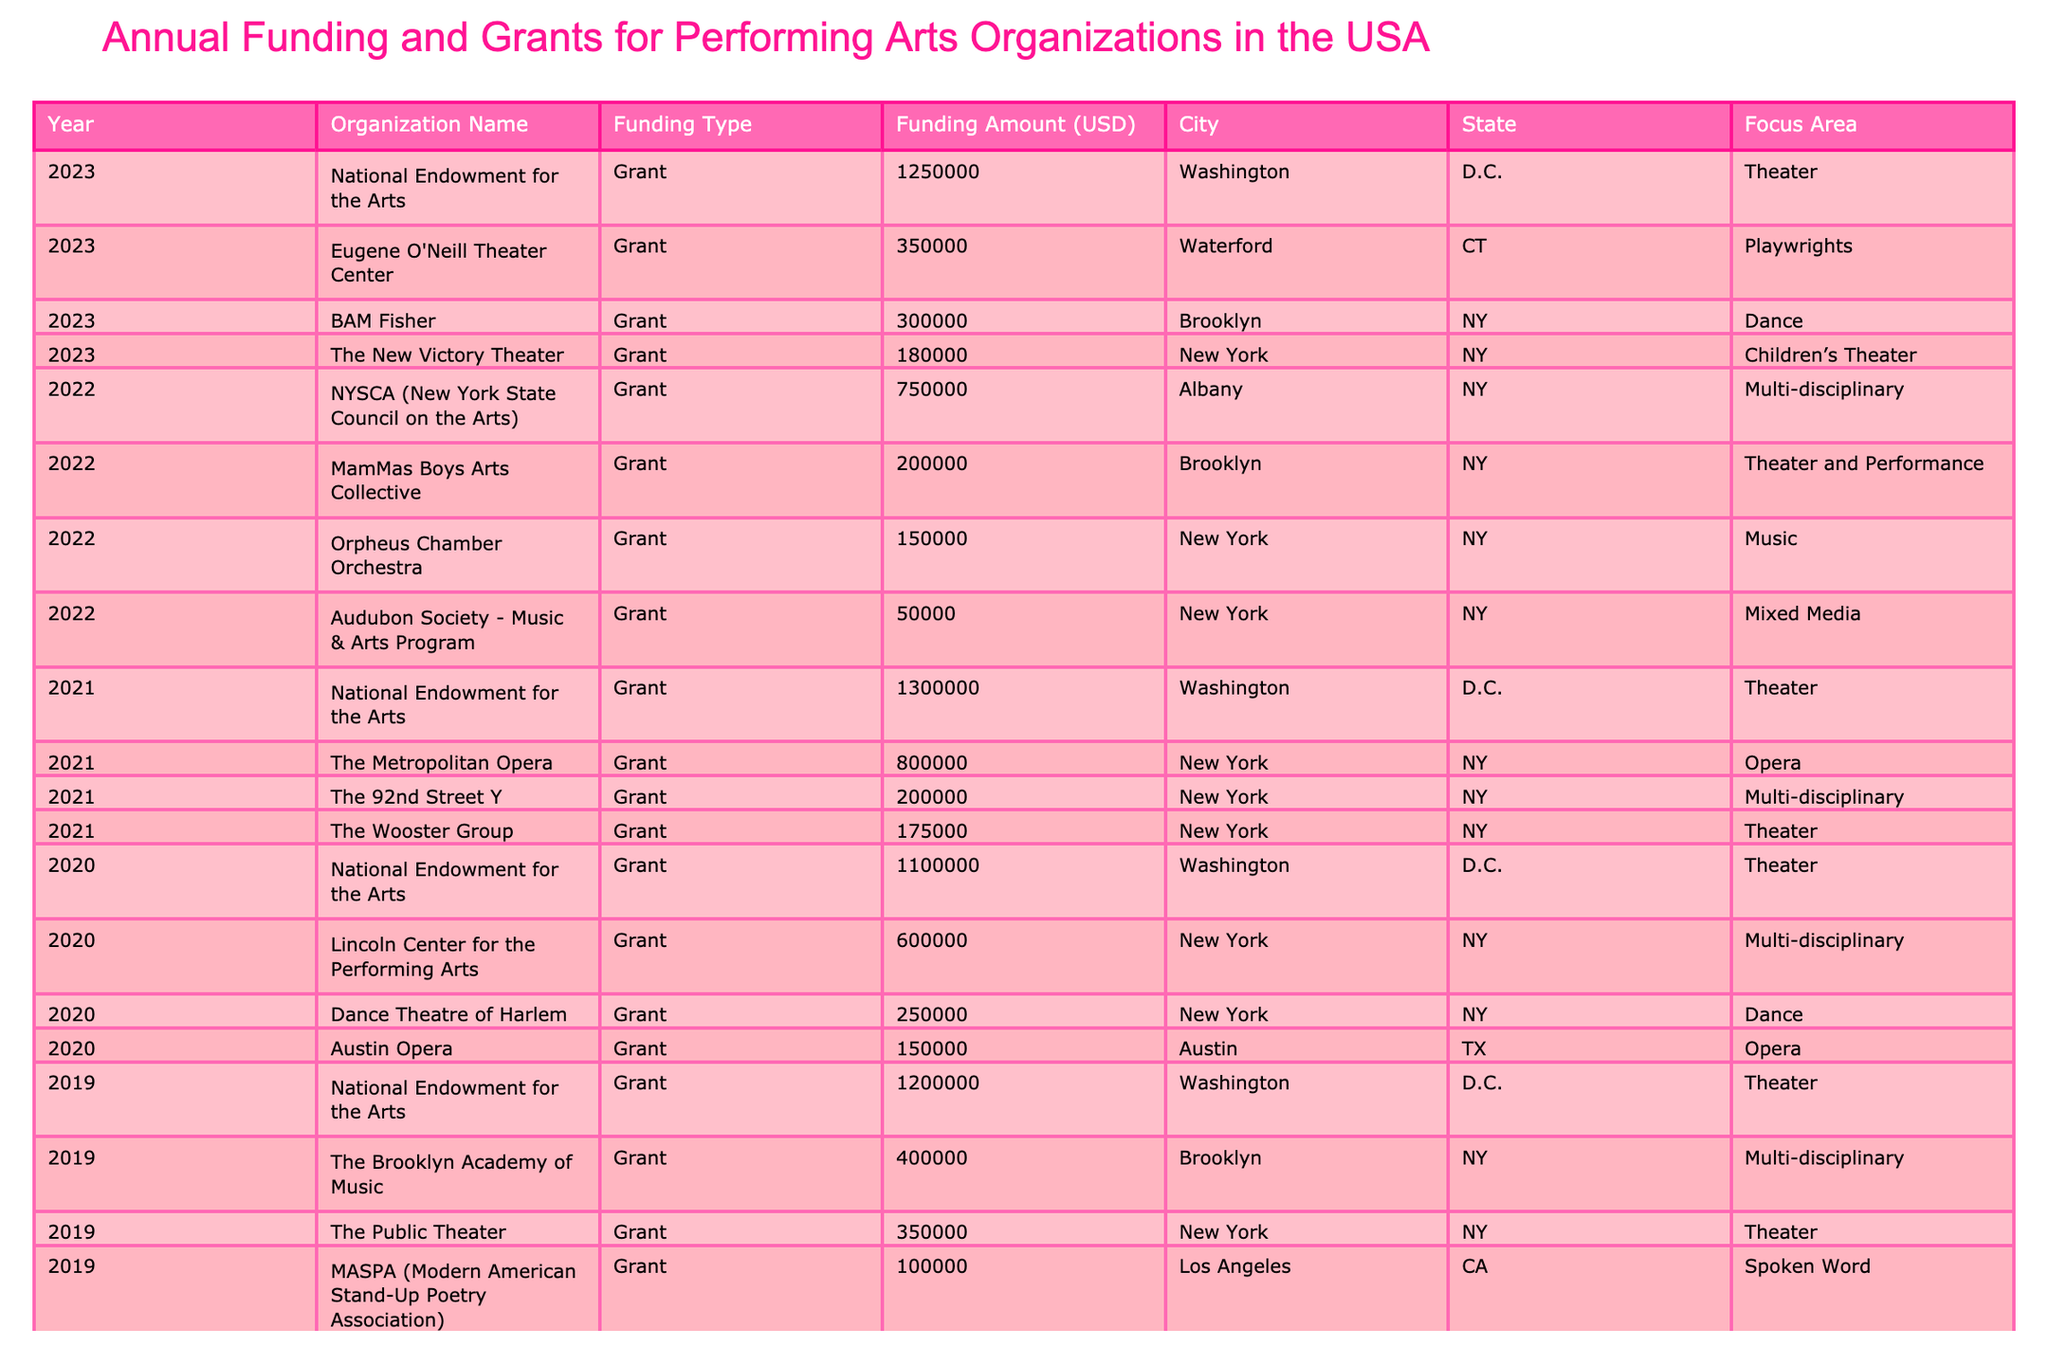What was the total funding amount for the National Endowment for the Arts from 2018 to 2023? The funding amounts for the National Endowment for the Arts are: 1,000,000 (2018), 1,200,000 (2019), 1,100,000 (2020), 1,300,000 (2021), 1,250,000 (2023). Adding these amounts together gives: 1,000,000 + 1,200,000 + 1,100,000 + 1,300,000 + 1,250,000 = 5,850,000.
Answer: 5,850,000 Which organization received the highest single grant in 2021? In 2021, the grants were: National Endowment for the Arts (1,300,000), Metropolitan Opera (800,000), 92nd Street Y (200,000), Wooster Group (175,000). The highest is the National Endowment for the Arts at 1,300,000.
Answer: National Endowment for the Arts How much funding was allocated to Dance organizations in 2020? The Dance organizations in 2020 received: Dance Theatre of Harlem (250,000). There are no other amounts listed under Dance for that year, thus the total is 250,000.
Answer: 250,000 Did the total funding for Performing Arts increase from 2018 to 2023? To assess the increase, we can summarize the total funding amounts for each year: 2018 (2,000,000), 2019 (2,170,000), 2020 (2,110,000), 2021 (2,475,000), 2022 (1,900,000), 2023 (2,310,000). From 2018 to 2023, the total starting from 2,000,000 shows an increase in majority years, concluding an overall rise.
Answer: Yes What is the average funding amount for the Brooklyn-based organizations across all years? The Brooklyn organizations received: 400,000 (2019 - Brooklyn Academy of Music), 200,000 (2021 - Wooster Group), 200,000 (2022 - MamMas Boys Arts Collective), 300,000 (2023 - BAM Fisher). Summing these amounts gives: 400,000 + 200,000 + 200,000 + 300,000 = 1,100,000, and averaging over 4 data points results in 1,100,000 / 4 = 275,000.
Answer: 275,000 Which state received the most funding overall for Performing Arts by 2023? Analyzing the total amounts per state: Washington, D.C. (5,850,000), New York (4,075,000), California (100,000), Texas (150,000), and others. Washington, D.C. has the highest total funding, indicating that it received the most.
Answer: Washington, D.C How much funding did the Opera sector receive in 2021 compared to 2022? In 2021, the Opera sector received 800,000 (Metropolitan Opera). In 2022, there is no funding listed for Opera. Therefore, the comparison shows 800,000 in 2021 and 0 in 2022, indicating a drop.
Answer: 800,000 in 2021, 0 in 2022 What is the total funding granted to organizations from New York between 2018 and 2023? The New York organizations received: 300,000 (Joyce Theater), 500,000 (Lincoln Center), 350,000 (Public Theater), 250,000 (Dance Theatre of Harlem), 800,000 (Metropolitan Opera), 200,000 (92nd Street Y), 0 in 2022 for Opera, and various amounts in 2023. Adding them gives a total of 2,200,000 from all years combined.
Answer: 2,200,000 Was there any year where no funding was allocated for Mixed Media? Mixed Media received funding only in 2022, so there were no allocations in the other years (2018-2021 and 2023). Therefore, yes, there were years without funding for Mixed Media.
Answer: Yes What is the difference between the total funding in the Theater area for 2019 and 2023? In 2019, the total funding for Theater is: 1,200,000 (NEA) + 350,000 (Public Theater) = 1,550,000. In 2023, the total for Theater is 1,250,000 (NEA), therefore, the difference is 1,550,000 - 1,250,000 = 300,000.
Answer: 300,000 